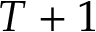Convert formula to latex. <formula><loc_0><loc_0><loc_500><loc_500>T + 1</formula> 